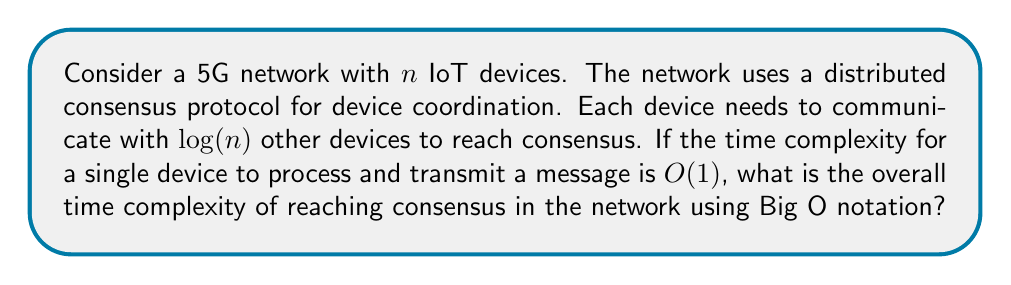Give your solution to this math problem. To solve this problem, we need to consider the following steps:

1) Each device needs to communicate with $\log(n)$ other devices.

2) For each communication, the time complexity is $O(1)$.

3) Therefore, for a single device, the time complexity is $O(\log(n))$.

4) However, we need to consider that all $n$ devices are performing this operation simultaneously.

5) In a distributed system, the overall time complexity is determined by the maximum time taken by any single node.

6) Since all nodes are performing the same operation, the overall time complexity remains $O(\log(n))$.

This result demonstrates the scalability of the 5G network protocol. As the number of devices increases, the time complexity grows logarithmically, which is much slower than linear growth. This is crucial for maintaining performance in large IoT deployments.

To visualize this scalability:

[asy]
import graph;
size(200,200);
real f(real x) {return log(x)/log(2);}
xaxis("Number of devices (n)",Arrow);
yaxis("Time complexity",Arrow);
draw(graph(f,1,100));
label("$O(\log n)$", (80,f(80)), E);
[/asy]

This graph shows how the time complexity (y-axis) grows as the number of devices (x-axis) increases. The logarithmic growth ensures that the protocol remains efficient even with a large number of devices.
Answer: The overall time complexity of reaching consensus in the network is $O(\log(n))$. 